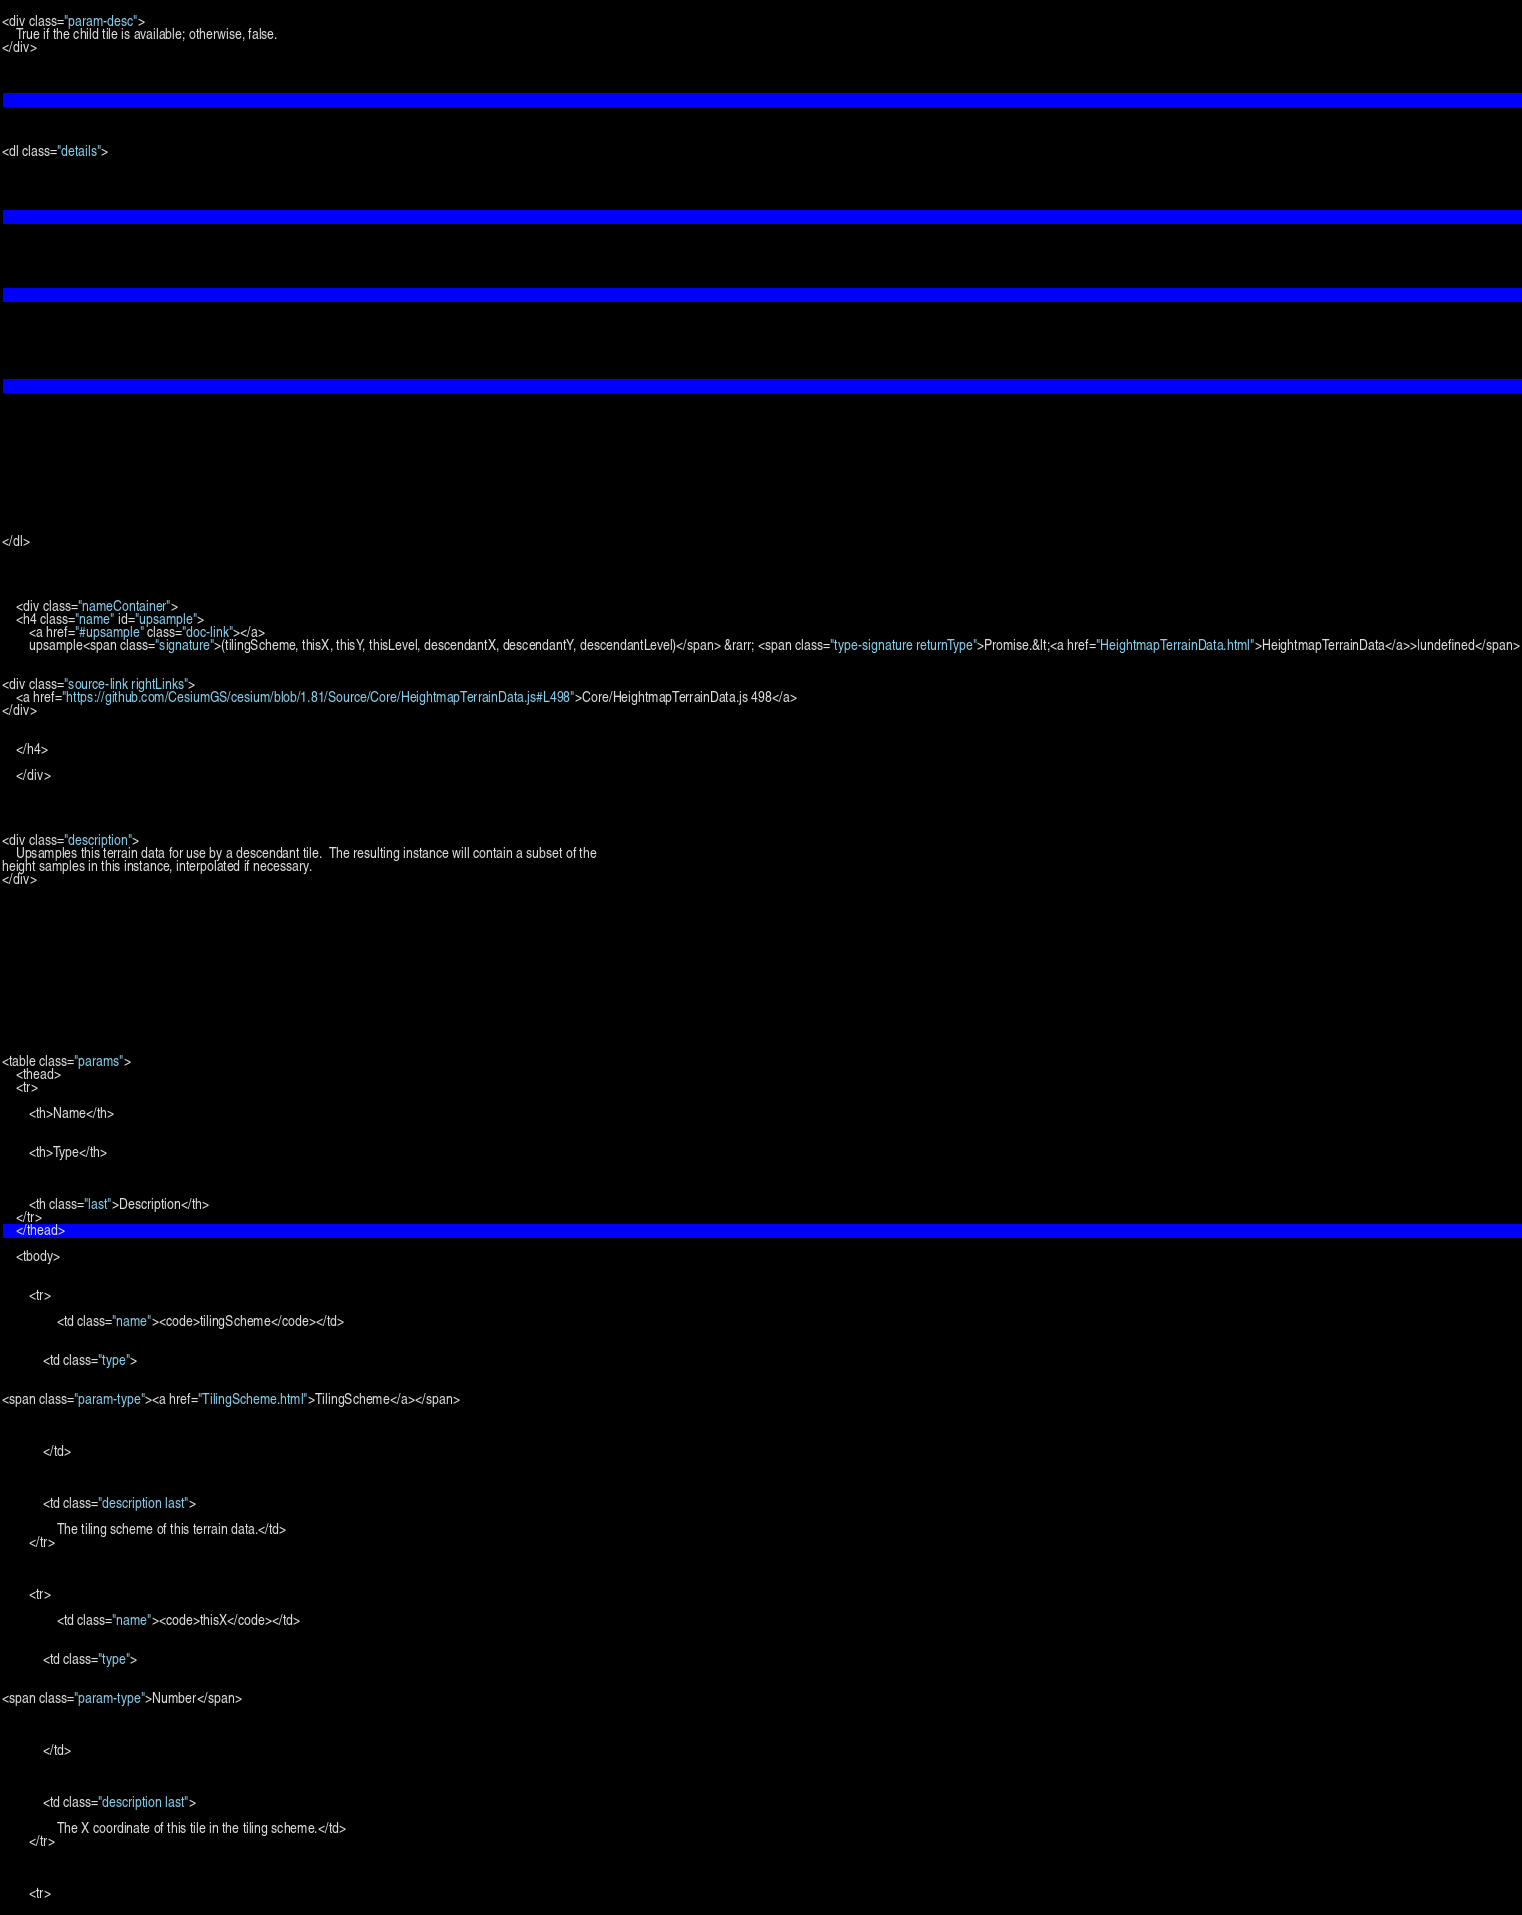<code> <loc_0><loc_0><loc_500><loc_500><_HTML_>
        
<div class="param-desc">
    True if the child tile is available; otherwise, false.
</div>


    




<dl class="details">


    

    

    

    

    

    

    

    

    

    

    

    

    

    
</dl>


        
            
    <div class="nameContainer">
    <h4 class="name" id="upsample">
        <a href="#upsample" class="doc-link"></a>
        upsample<span class="signature">(tilingScheme, thisX, thisY, thisLevel, descendantX, descendantY, descendantLevel)</span> &rarr; <span class="type-signature returnType">Promise.&lt;<a href="HeightmapTerrainData.html">HeightmapTerrainData</a>>|undefined</span>
        

<div class="source-link rightLinks">
    <a href="https://github.com/CesiumGS/cesium/blob/1.81/Source/Core/HeightmapTerrainData.js#L498">Core/HeightmapTerrainData.js 498</a>
</div>


    </h4>

    </div>

    


<div class="description">
    Upsamples this terrain data for use by a descendant tile.  The resulting instance will contain a subset of the
height samples in this instance, interpolated if necessary.
</div>











    

<table class="params">
    <thead>
    <tr>
        
        <th>Name</th>
        

        <th>Type</th>

        

        <th class="last">Description</th>
    </tr>
    </thead>

    <tbody>
    

        <tr>
            
                <td class="name"><code>tilingScheme</code></td>
            

            <td class="type">
            
                
<span class="param-type"><a href="TilingScheme.html">TilingScheme</a></span>


            
            </td>

            

            <td class="description last">
            
                The tiling scheme of this terrain data.</td>
        </tr>

    

        <tr>
            
                <td class="name"><code>thisX</code></td>
            

            <td class="type">
            
                
<span class="param-type">Number</span>


            
            </td>

            

            <td class="description last">
            
                The X coordinate of this tile in the tiling scheme.</td>
        </tr>

    

        <tr>
            </code> 